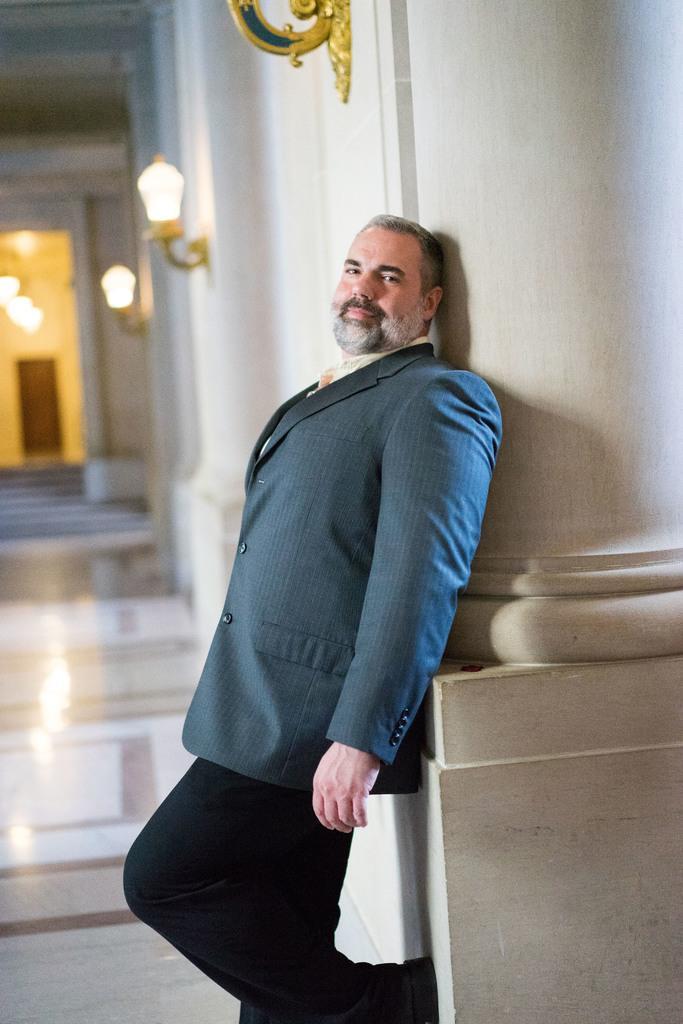Describe this image in one or two sentences. In this image there is a person standing near the pillar. He is wearing a suit. Few lights are attached to the wall. Left side there are stairs. Behind there is a door to the wall. Few lights are attached to the roof. 